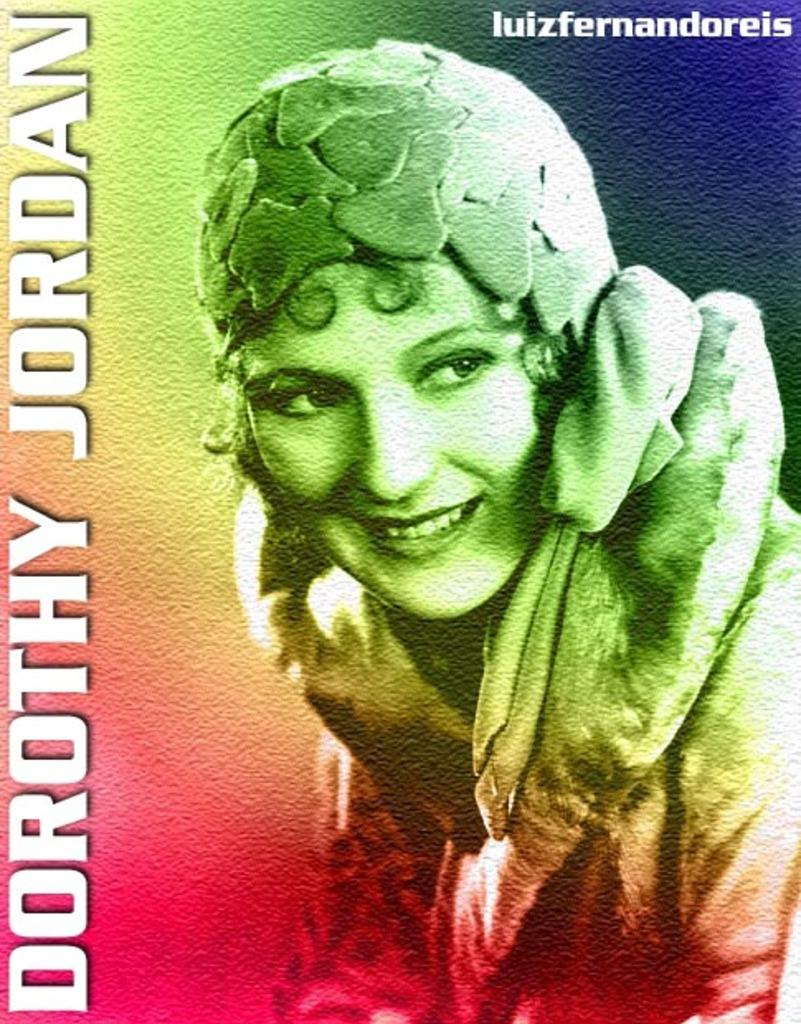What type of artwork is shown in the image? The image appears to be a painting. Who or what is the main subject of the painting? There is a woman depicted in the painting. Are there any words or letters in the painting? Yes, there is text present in the painting. How would you describe the background of the painting? The background of the painting is multicolored. What type of egg is being used for the activity in the painting? There is no egg or activity present in the painting; it features a woman and text in a multicolored background. 